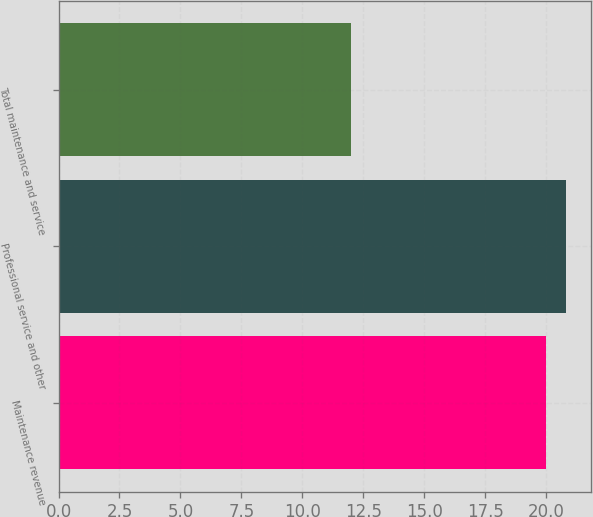Convert chart. <chart><loc_0><loc_0><loc_500><loc_500><bar_chart><fcel>Maintenance revenue<fcel>Professional service and other<fcel>Total maintenance and service<nl><fcel>20<fcel>20.8<fcel>12<nl></chart> 